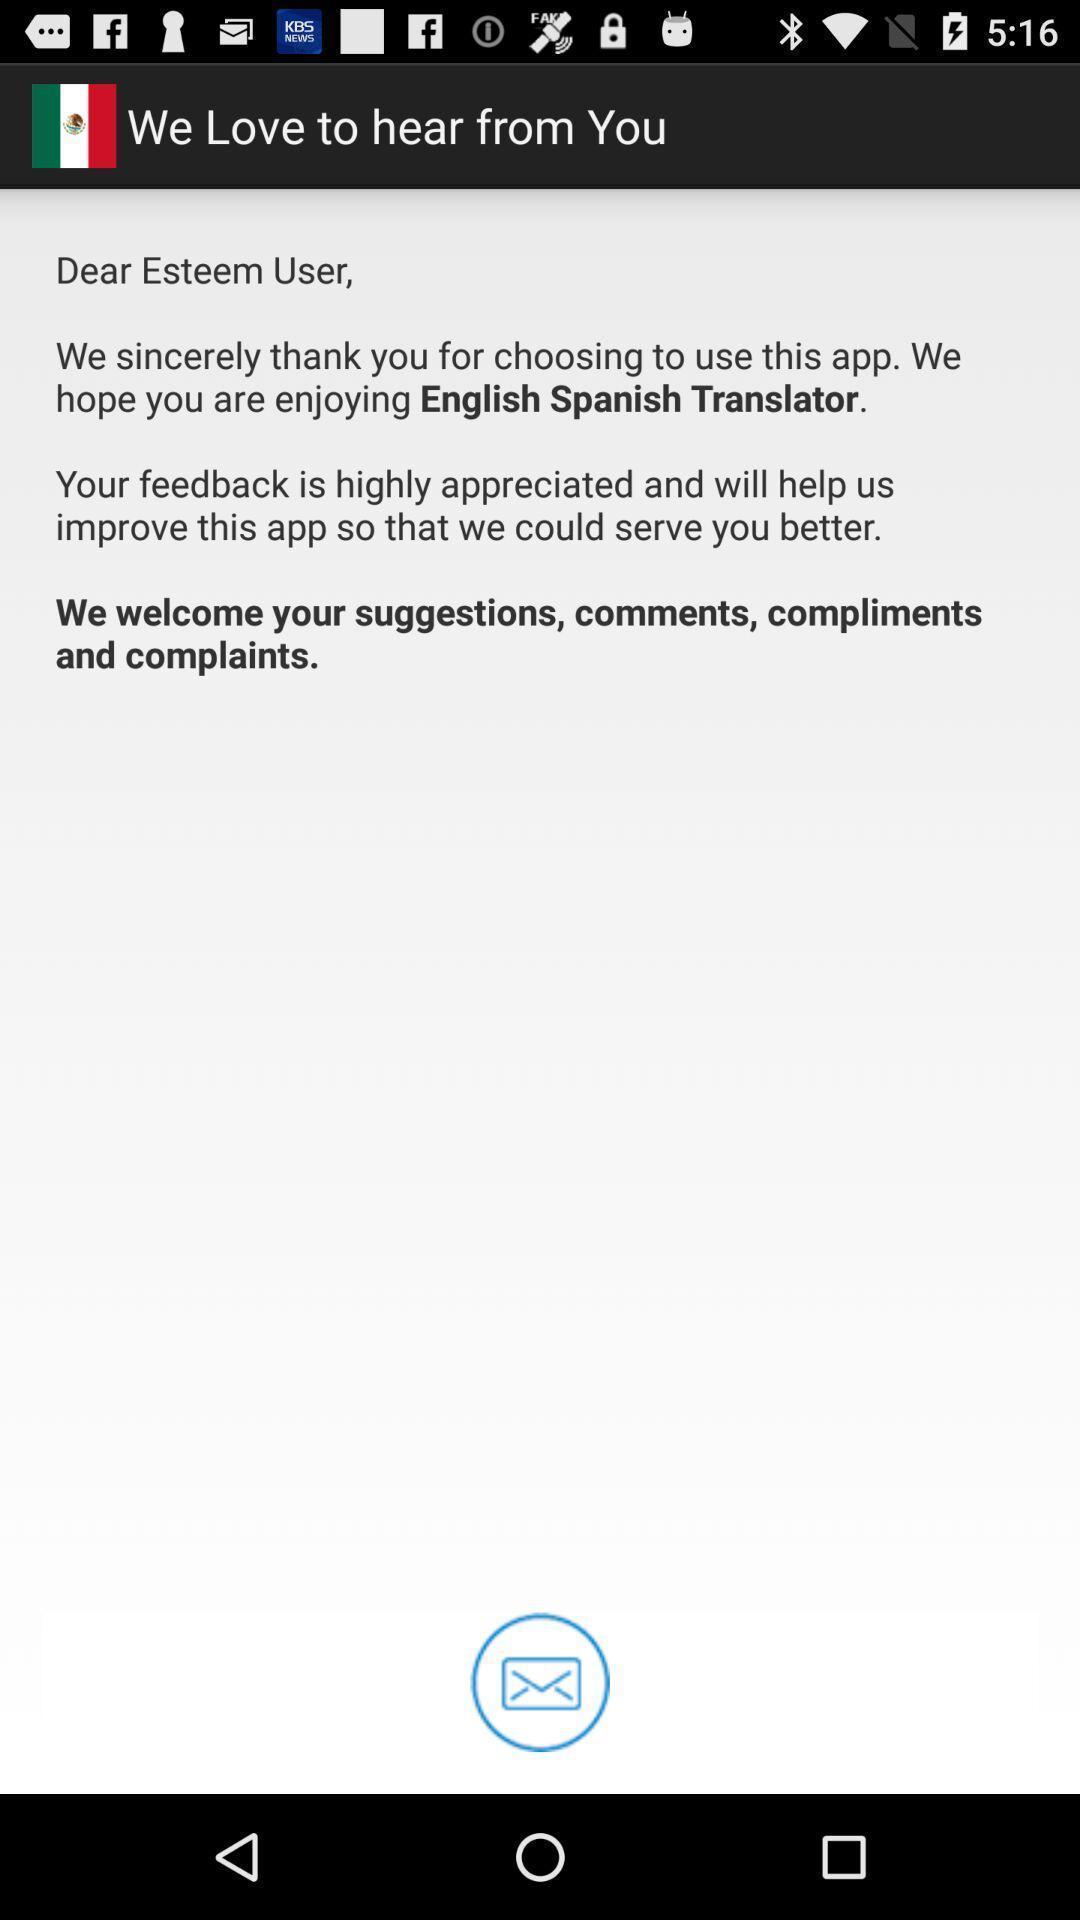Explain the elements present in this screenshot. Page shows some information in an language application. 